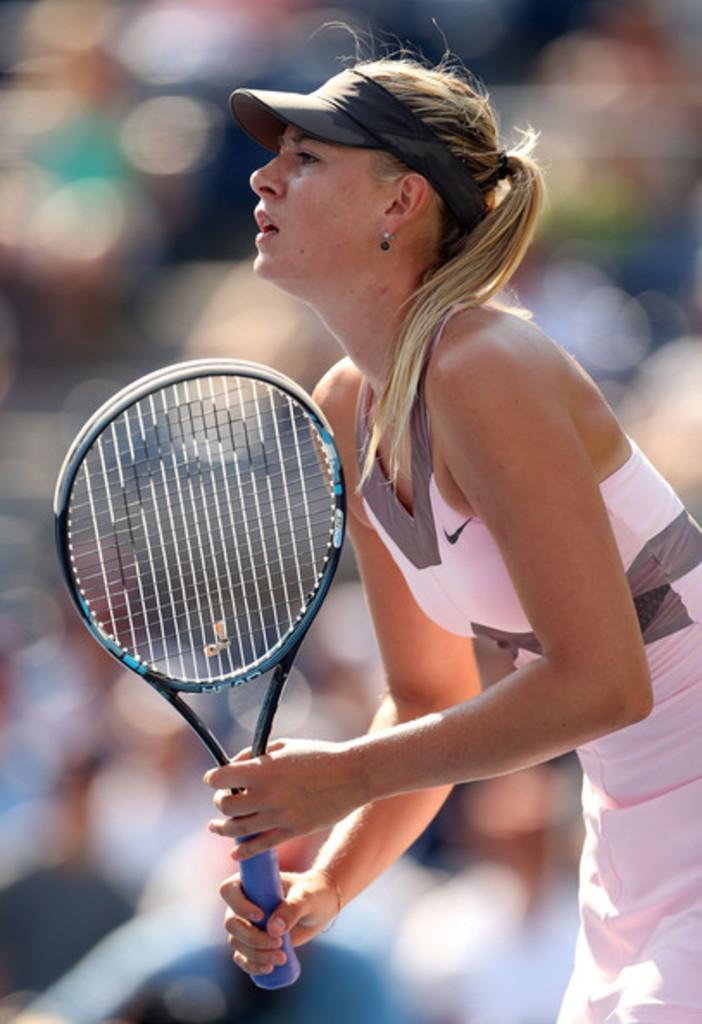Who is the main subject in the image? There is a girl in the center of the image. What is the girl holding in the image? The girl is holding a tennis bat. Can you describe the background of the image? The background of the image is blurred. What color is the receipt in the girl's hand in the image? There is no receipt present in the image; the girl is holding a tennis bat. 